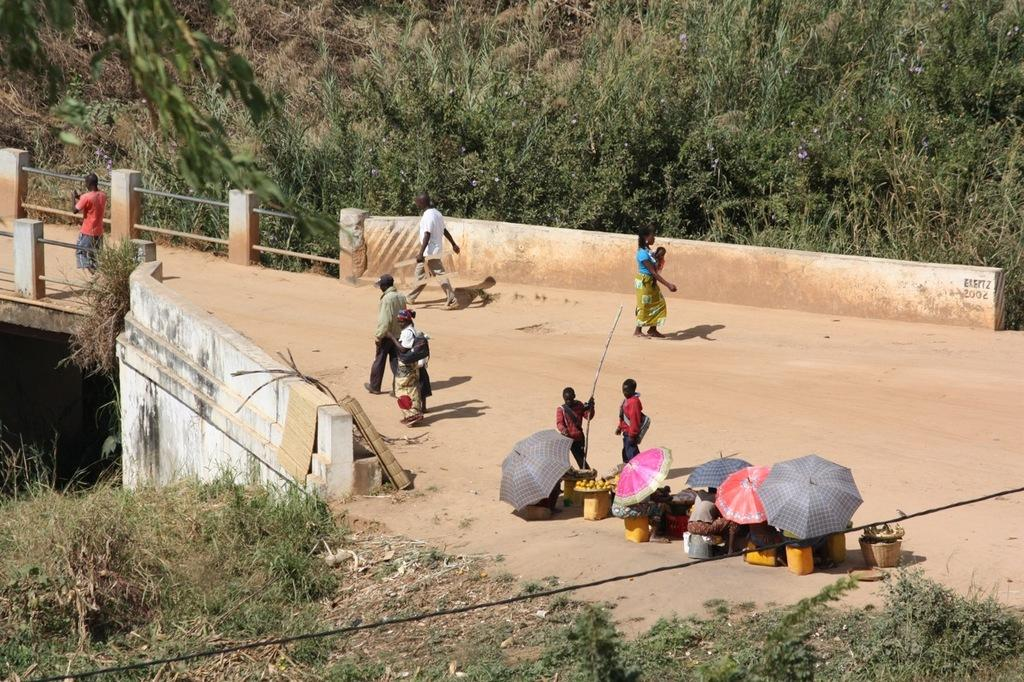What can be seen on the road in the image? There are persons on the road in the image. What objects are visible in the image that might be used for protection from the elements? There are umbrellas in the image. What items are present that might be used for carrying or holding items? There are baskets in the image. What type of food can be seen in the image? There are fruits in the image. What type of natural environment is visible in the image? There is grass in the image. What type of structure is visible in the image that might allow people to cross a body of water? There is a bridge in the image. What type of vegetation can be seen in the background of the image? There are plants in the background of the image. Where is the crook hiding in the image? There is no crook present in the image. What type of room can be seen in the background of the image? There is no room visible in the image; it features a natural outdoor setting. 